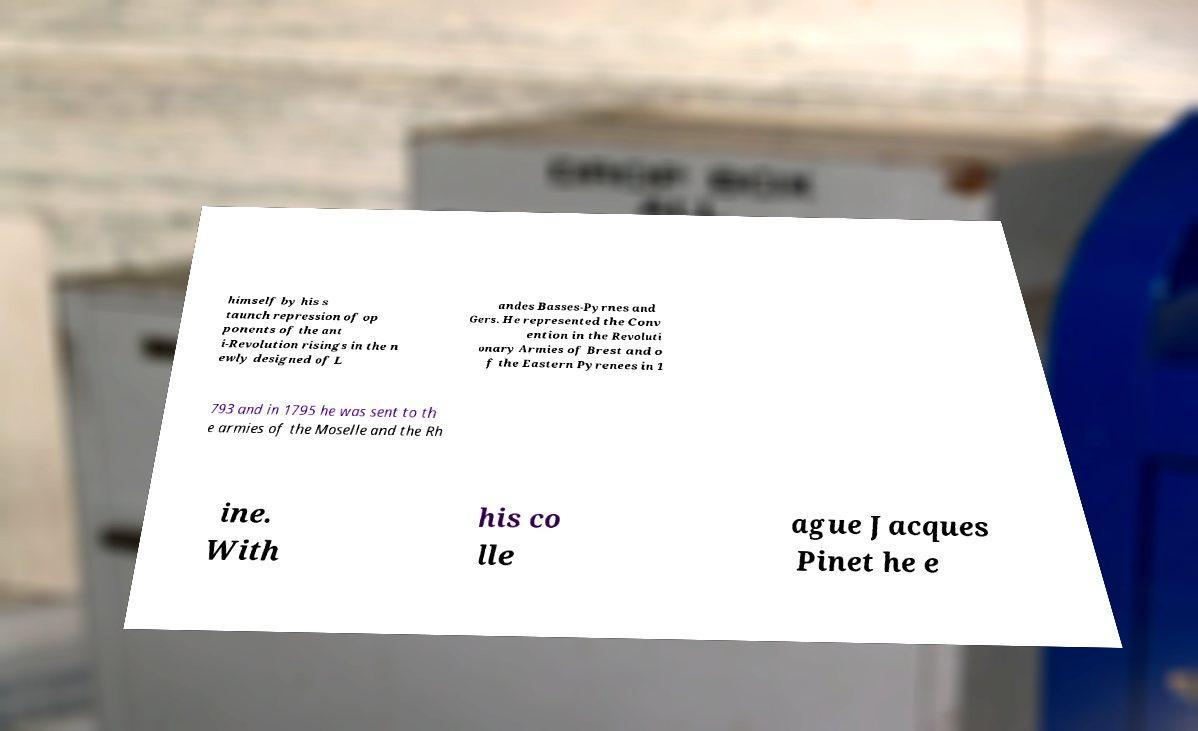Please identify and transcribe the text found in this image. himself by his s taunch repression of op ponents of the ant i-Revolution risings in the n ewly designed of L andes Basses-Pyrnes and Gers. He represented the Conv ention in the Revoluti onary Armies of Brest and o f the Eastern Pyrenees in 1 793 and in 1795 he was sent to th e armies of the Moselle and the Rh ine. With his co lle ague Jacques Pinet he e 